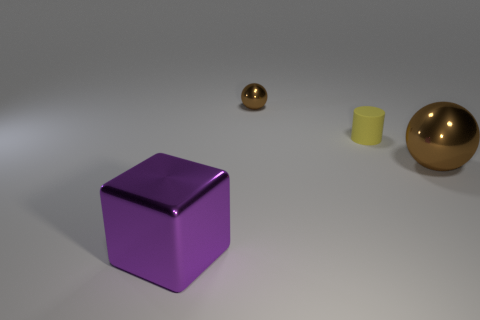Add 4 big purple cubes. How many objects exist? 8 Subtract all cylinders. How many objects are left? 3 Add 3 purple rubber things. How many purple rubber things exist? 3 Subtract 0 blue cylinders. How many objects are left? 4 Subtract 1 spheres. How many spheres are left? 1 Subtract all red cylinders. Subtract all green blocks. How many cylinders are left? 1 Subtract all purple rubber cubes. Subtract all big blocks. How many objects are left? 3 Add 4 brown shiny spheres. How many brown shiny spheres are left? 6 